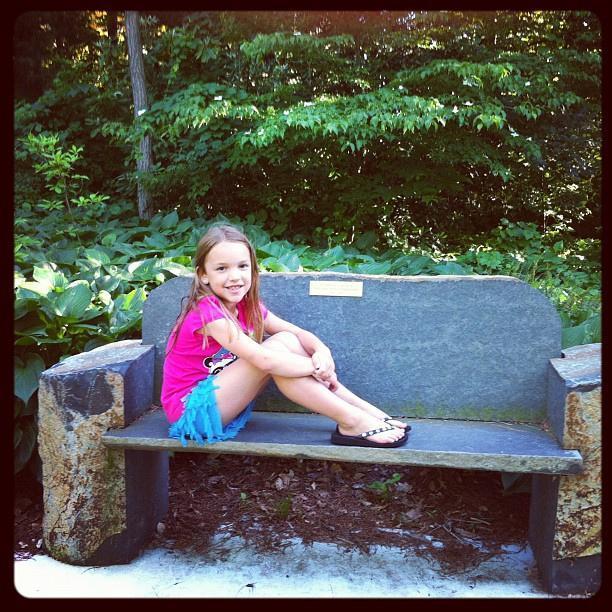How many people are in the picture?
Give a very brief answer. 1. 